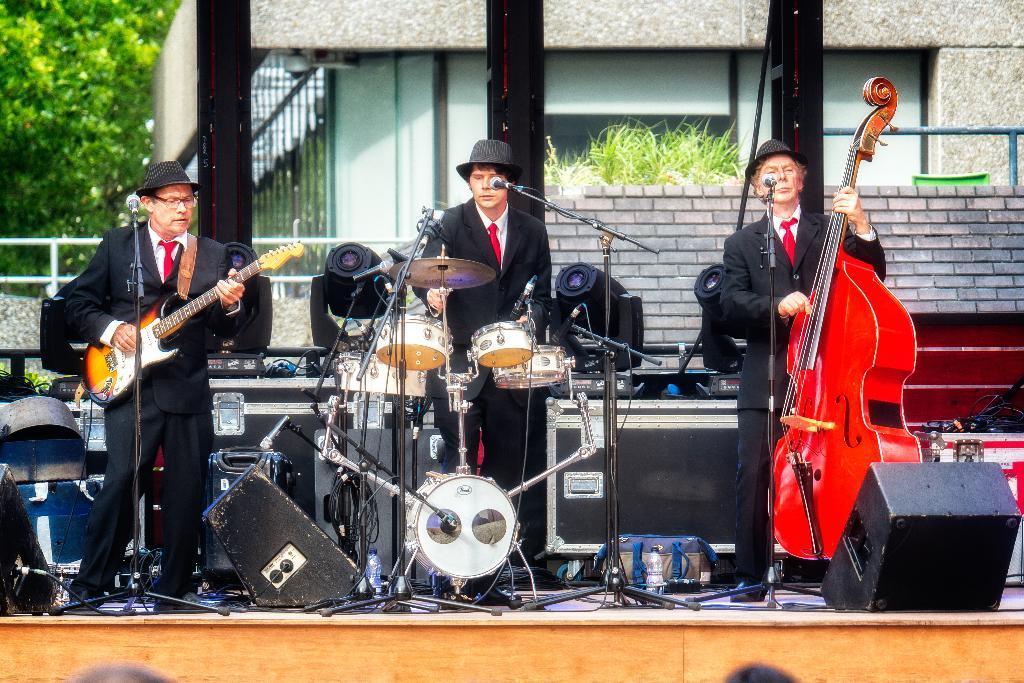Could you give a brief overview of what you see in this image? There are 3 men on the stage performing by playing musical instruments. In the background there is a building,trees and a pole. 